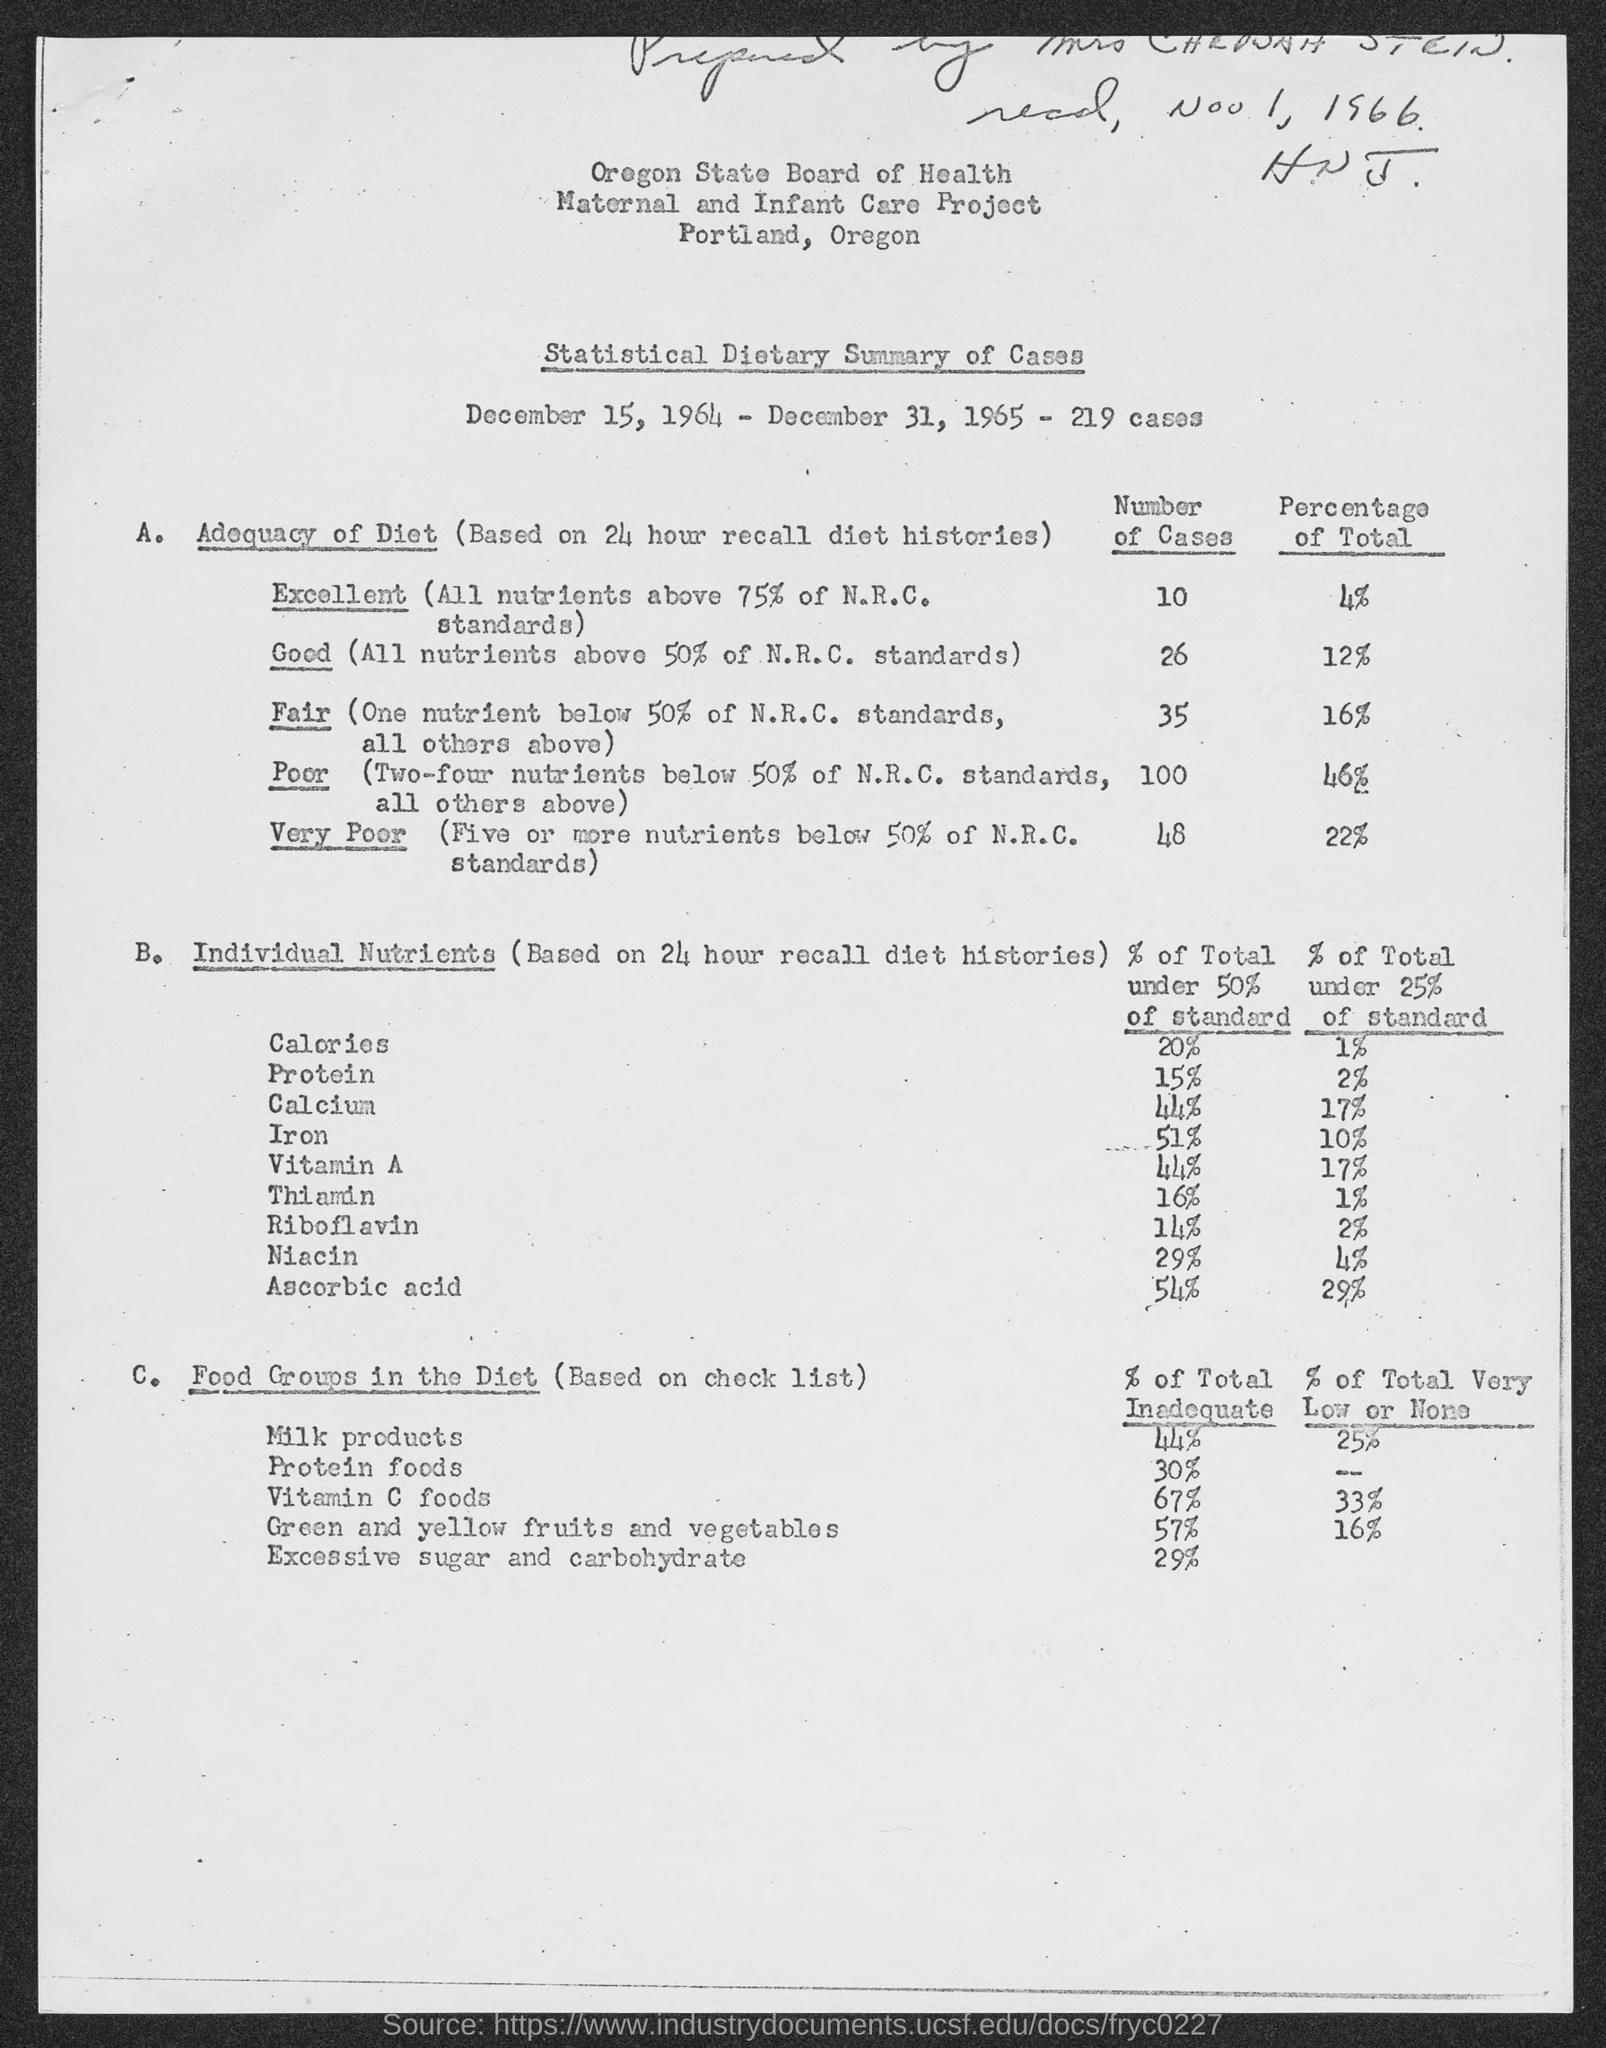Draw attention to some important aspects in this diagram. The milk product's contribution to the total inadequate intake is 44%. The calories percentage of a given amount is less than 50% of the standard amount. There were 219 cases from December 15, 1964 to December 31, 1965. There were 10 cases with an excellent diet. 